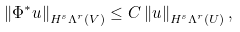Convert formula to latex. <formula><loc_0><loc_0><loc_500><loc_500>\left \| \Phi ^ { * } u \right \| _ { H ^ { s } \Lambda ^ { r } ( V ) } \leq C \left \| u \right \| _ { H ^ { s } \Lambda ^ { r } ( U ) } ,</formula> 